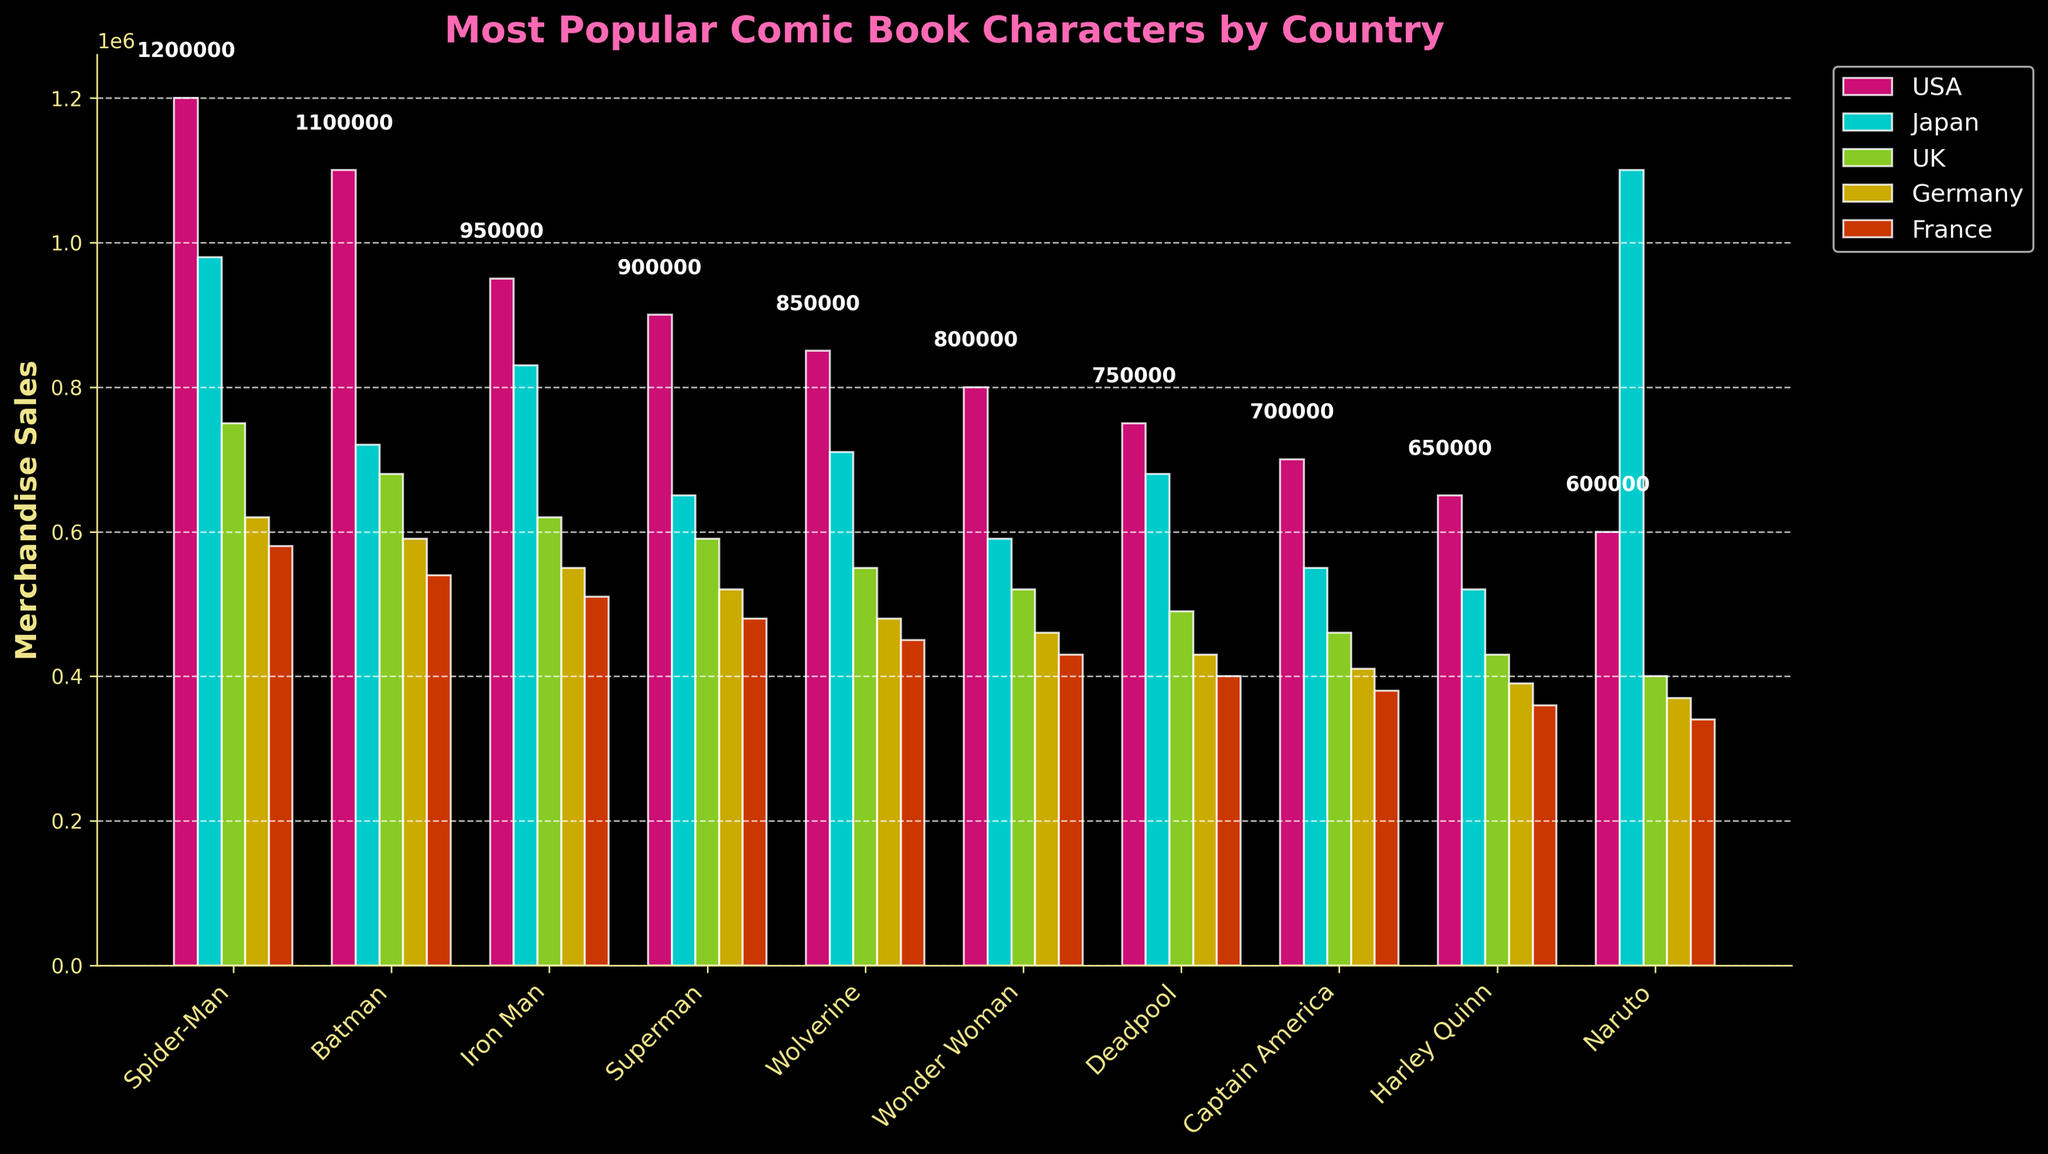How many countries have Spider-Man as the most popular character based on merchandise sales? Look at the height of the bars for Spider-Man in each country and compare them with the heights of the bars for other characters. Spider-Man has the highest bar in the USA and France.
Answer: 2 Which character has the second highest sales in Japan? Look at the heights of all the bars in Japan. Naruto has the highest bar, and Spider-Man has the second highest.
Answer: Spider-Man Is the total merchandise sales of Batman higher than Superman across all shown countries? Sum up the merchandise sales for Batman and Superman across all countries. Batman's total is 1100000 + 720000 + 680000 + 590000 + 540000 = 3610000, while Superman's total is 900000 + 650000 + 590000 + 520000 + 480000 = 3140000.
Answer: Yes What is the average merchandise sales for Iron Man in the given countries? Add up the merchandise sales for Iron Man across all countries and divide by the number of countries: (950000 + 830000 + 620000 + 550000 + 510000) / 5 = 3460000 / 5
Answer: 692000 Compare the merchandise sales of Wonder Woman in the USA and Germany. Which country has higher sales? Look at the heights of the bars for Wonder Woman in the USA and Germany. The USA has a sales figure of 800000, while Germany has 460000.
Answer: USA How much more merchandise sales does Spider-Man have in the USA compared to Japan? Find the difference in merchandise sales for Spider-Man between the USA and Japan: 1200000 - 980000 = 220000
Answer: 220000 Which character has the least sales in the UK, and what is the value? Look for the shortest bar in the UK section of the chart. Naruto has the shortest bar with 400000.
Answer: Naruto, 400000 Between Deadpool and Captain America, which character has higher merchandise sales in Germany? Compare the heights of the bars for Deadpool and Captain America in Germany. Deadpool has 430000, while Captain America has 410000.
Answer: Deadpool Which country has the least merchandise sales for Wolverine, and what is the value? Look for the shortest bar for Wolverine across all countries. France has the lowest sales with 450000.
Answer: France, 450000 What is the sum of merchandise sales for Harley Quinn across the USA and the UK? Add the merchandise sales for Harley Quinn in the USA and the UK: 650000 + 430000 = 1080000
Answer: 1080000 